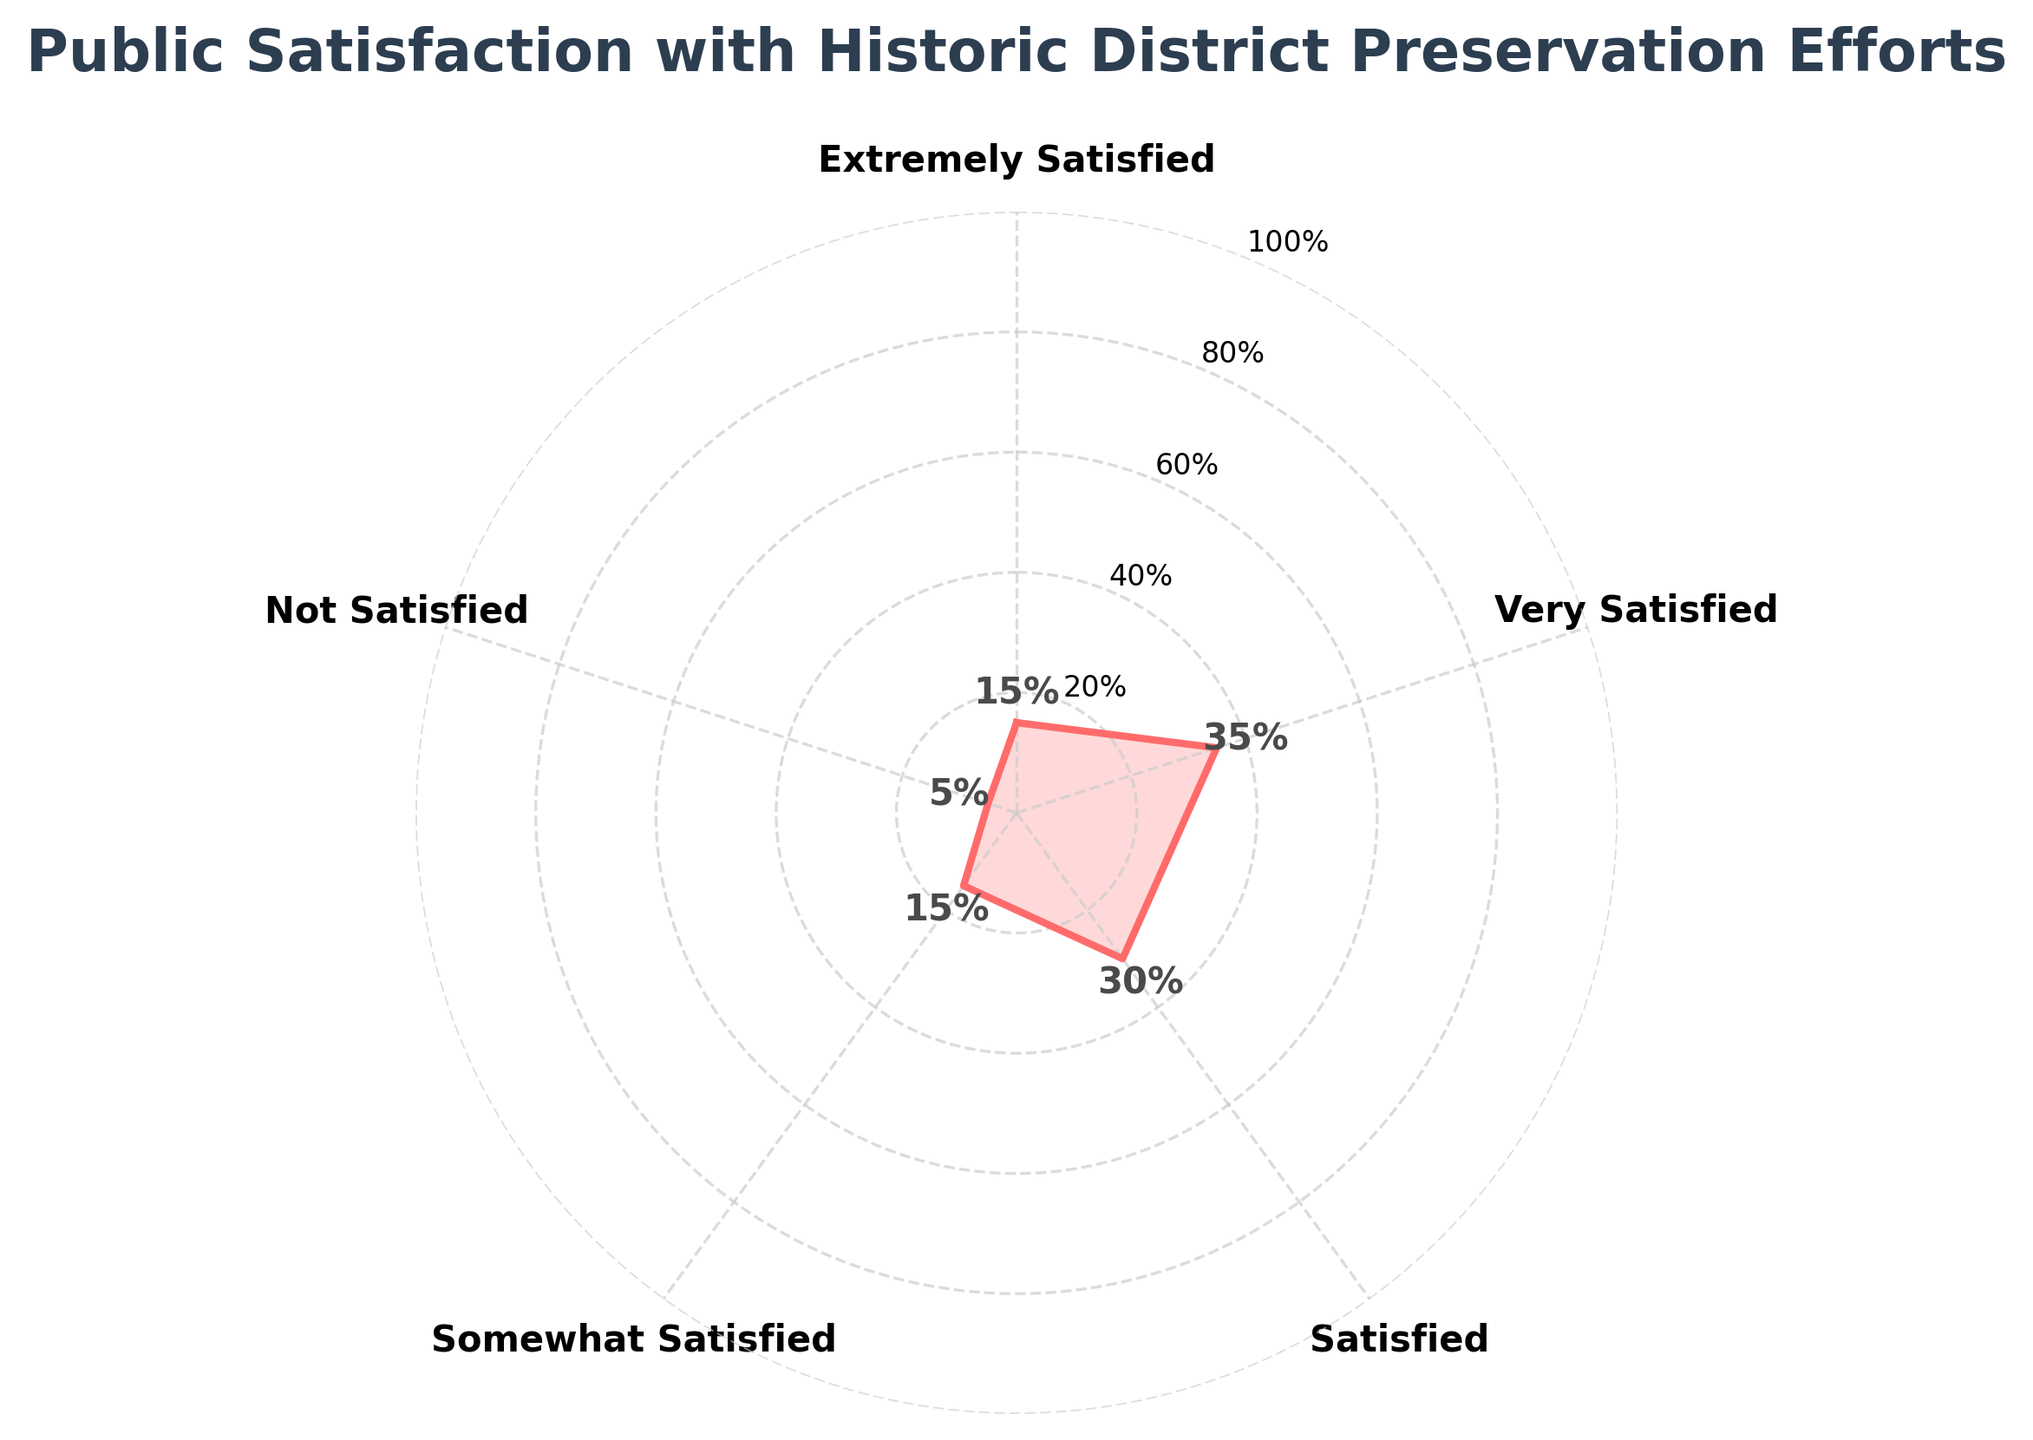what is the title of the figure? The title is written at the top of the figure and it reads 'Public Satisfaction with Historic District Preservation Efforts'.
Answer: Public Satisfaction with Historic District Preservation Efforts What color are the lines and filled areas representing satisfaction levels? The lines and filled areas representing satisfaction levels are shown in a specific color in the figure.
Answer: Red How many different levels of satisfaction are represented in the plot? By looking at the labels on the plot's axes, you can count the different levels of satisfaction represented.
Answer: 5 Which satisfaction level has the highest percentage of respondents? By looking at the points and their corresponding labels, you can identify the satisfaction level that reaches the highest value on the radial plot.
Answer: Very Satisfied What percentage of respondents are 'Somewhat Satisfied'? By locating the 'Somewhat Satisfied' category on the radial plot and reading the associated value, you can determine the percentage.
Answer: 15% Which two satisfaction levels have an equal percentage of respondents? By comparing the values around the radial plot, identify the two satisfaction levels that both reach the same value.
Answer: Extremely Satisfied and Somewhat Satisfied What is the total percentage of respondents who are 'Very Satisfied' and 'Satisfied'? Add the percentage values for 'Very Satisfied' and 'Satisfied' by reading them from the radial plot. 'Very Satisfied' has 35% and 'Satisfied' has 30%. Sum them up: 35% + 30% = 65%.
Answer: 65% Compare the percentages of 'Not Satisfied' and 'Extremely Satisfied'. Which is greater? By identifying the points labeled 'Not Satisfied' and 'Extremely Satisfied', you can compare their positions: 'Not Satisfied' is 5% and 'Extremely Satisfied' is 15%. Therefore, 'Extremely Satisfied' is greater.
Answer: Extremely Satisfied What average percentage of respondents are at or above being 'Satisfied'? To calculate the average, take the values for 'Satisfied', 'Very Satisfied', and 'Extremely Satisfied': 30%, 35%, and 15%. Sum them: 30 + 35 + 15 = 80. There are three categories so divide by 3: 80 / 3 ≈ 26.67%.
Answer: 26.67% 